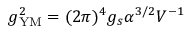Convert formula to latex. <formula><loc_0><loc_0><loc_500><loc_500>g _ { Y M } ^ { 2 } = ( 2 \pi ) ^ { 4 } g _ { s } \alpha ^ { 3 / 2 } V ^ { - 1 }</formula> 